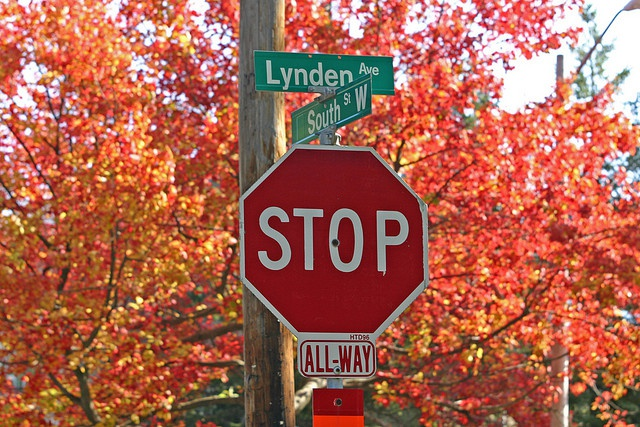Describe the objects in this image and their specific colors. I can see a stop sign in lavender, maroon, darkgray, and gray tones in this image. 